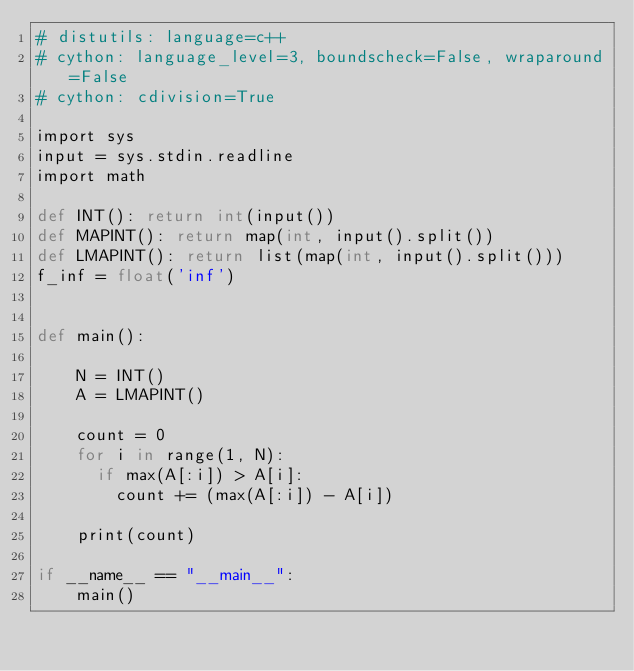<code> <loc_0><loc_0><loc_500><loc_500><_Cython_># distutils: language=c++
# cython: language_level=3, boundscheck=False, wraparound=False
# cython: cdivision=True

import sys
input = sys.stdin.readline
import math

def INT(): return int(input())
def MAPINT(): return map(int, input().split())
def LMAPINT(): return list(map(int, input().split()))
f_inf = float('inf')


def main():

    N = INT()
    A = LMAPINT()
    
    count = 0
    for i in range(1, N):
      if max(A[:i]) > A[i]:
        count += (max(A[:i]) - A[i])

    print(count)

if __name__ == "__main__":
    main()
</code> 